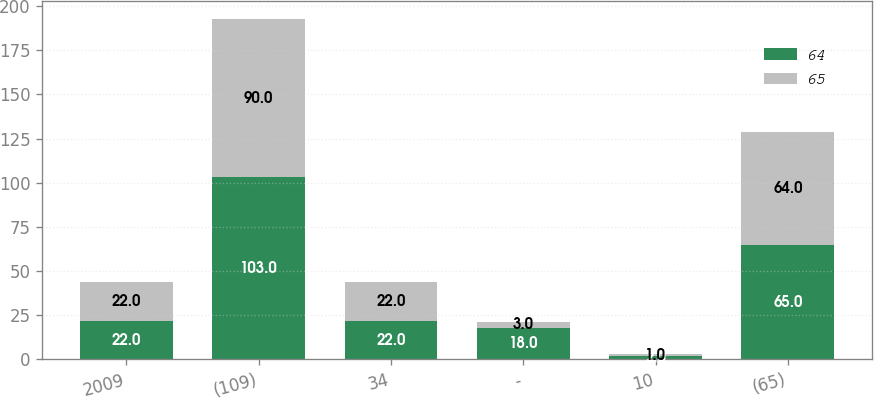Convert chart to OTSL. <chart><loc_0><loc_0><loc_500><loc_500><stacked_bar_chart><ecel><fcel>2009<fcel>(109)<fcel>34<fcel>-<fcel>10<fcel>(65)<nl><fcel>64<fcel>22<fcel>103<fcel>22<fcel>18<fcel>2<fcel>65<nl><fcel>65<fcel>22<fcel>90<fcel>22<fcel>3<fcel>1<fcel>64<nl></chart> 